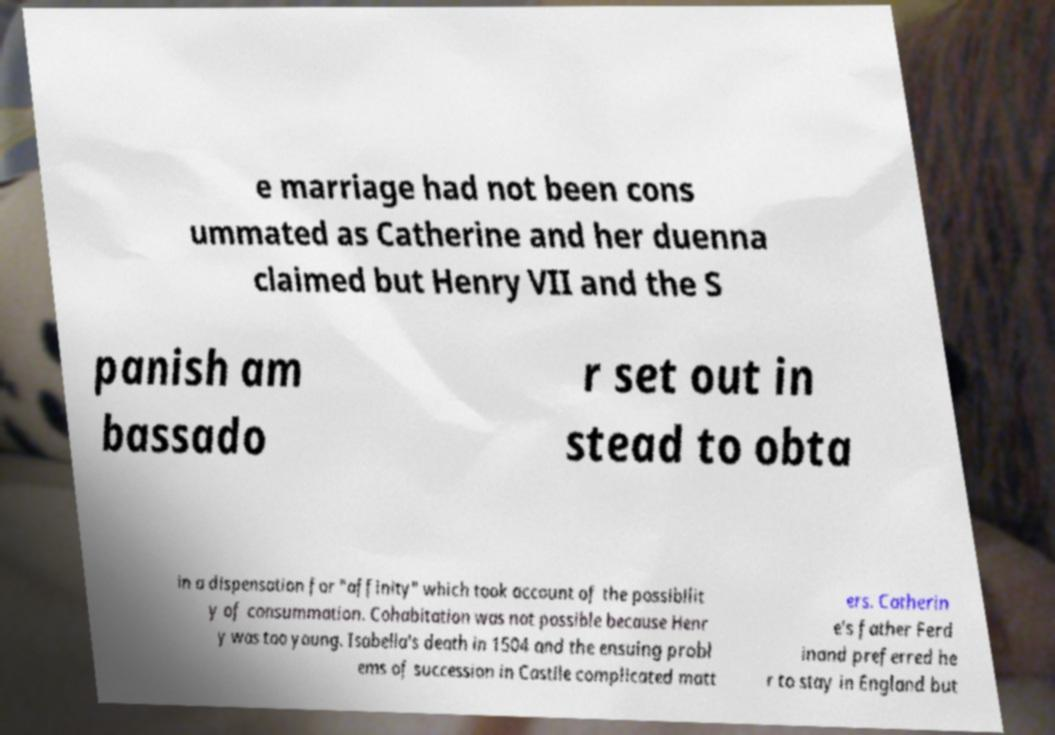Could you assist in decoding the text presented in this image and type it out clearly? e marriage had not been cons ummated as Catherine and her duenna claimed but Henry VII and the S panish am bassado r set out in stead to obta in a dispensation for "affinity" which took account of the possibilit y of consummation. Cohabitation was not possible because Henr y was too young. Isabella's death in 1504 and the ensuing probl ems of succession in Castile complicated matt ers. Catherin e's father Ferd inand preferred he r to stay in England but 